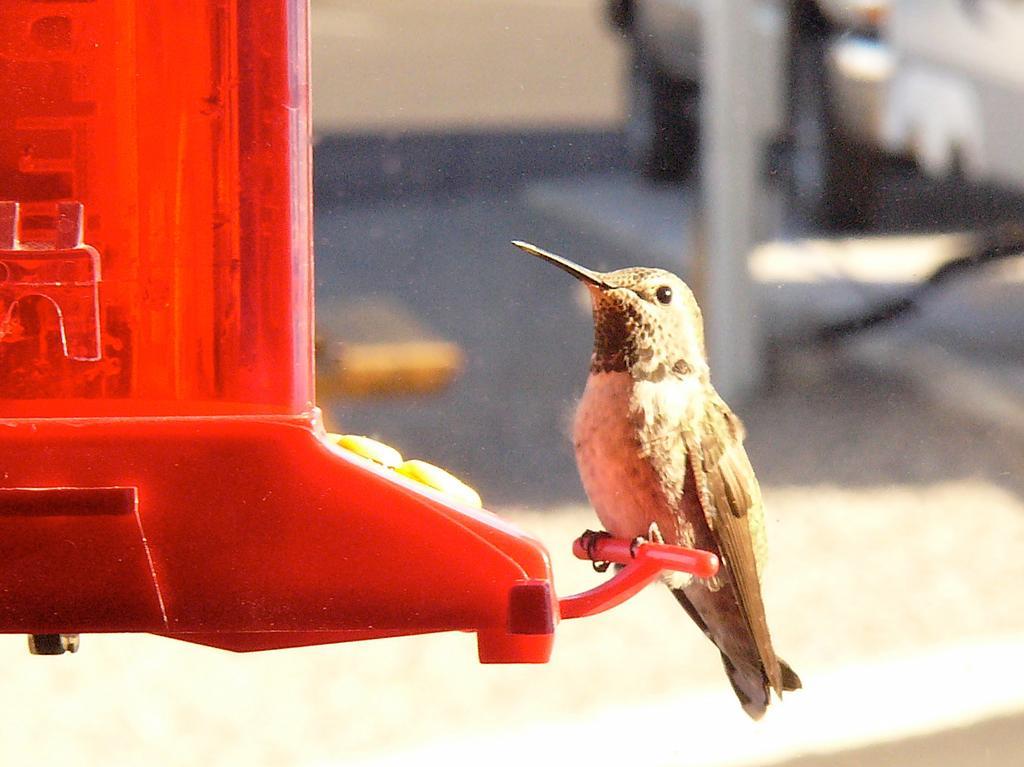Could you give a brief overview of what you see in this image? This image consists of a bird. This is clicked outside. It has feathers, eyes, beak, legs. 